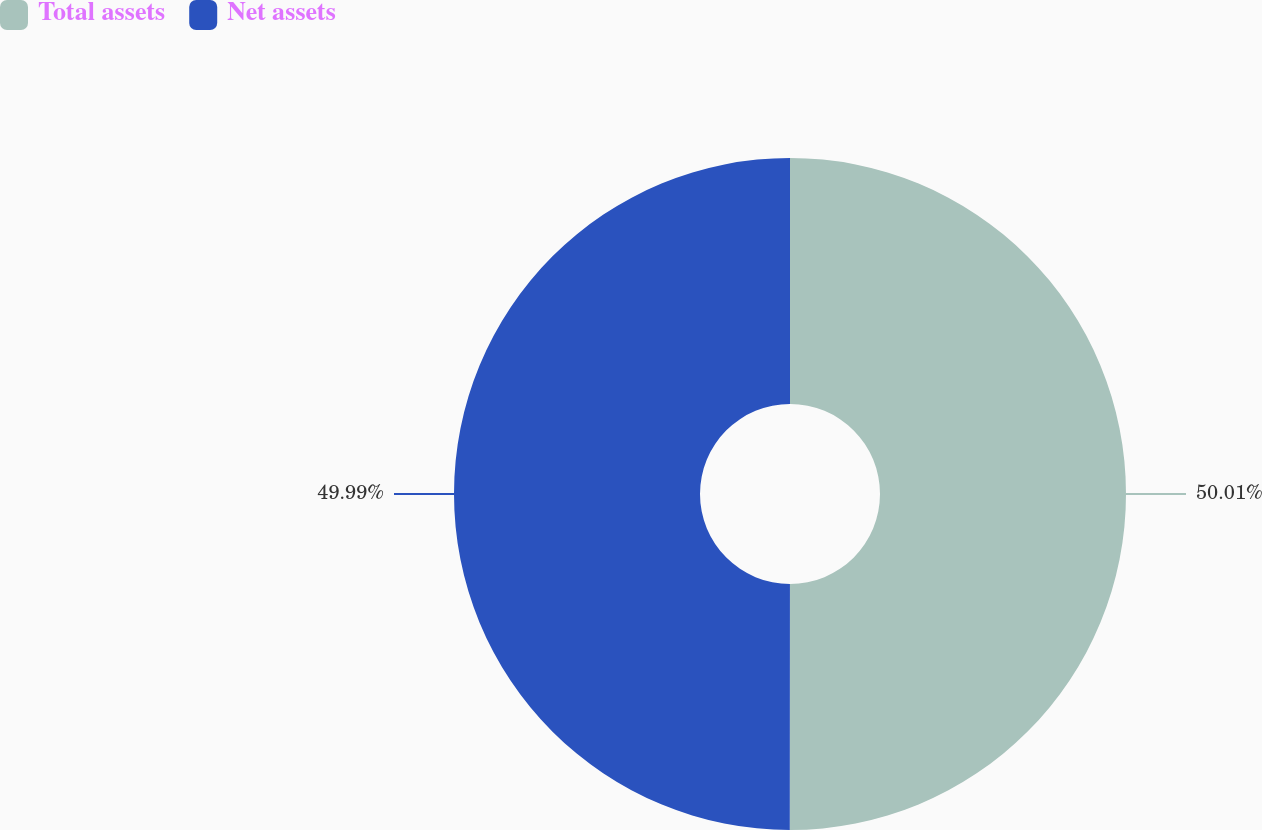Convert chart to OTSL. <chart><loc_0><loc_0><loc_500><loc_500><pie_chart><fcel>Total assets<fcel>Net assets<nl><fcel>50.01%<fcel>49.99%<nl></chart> 